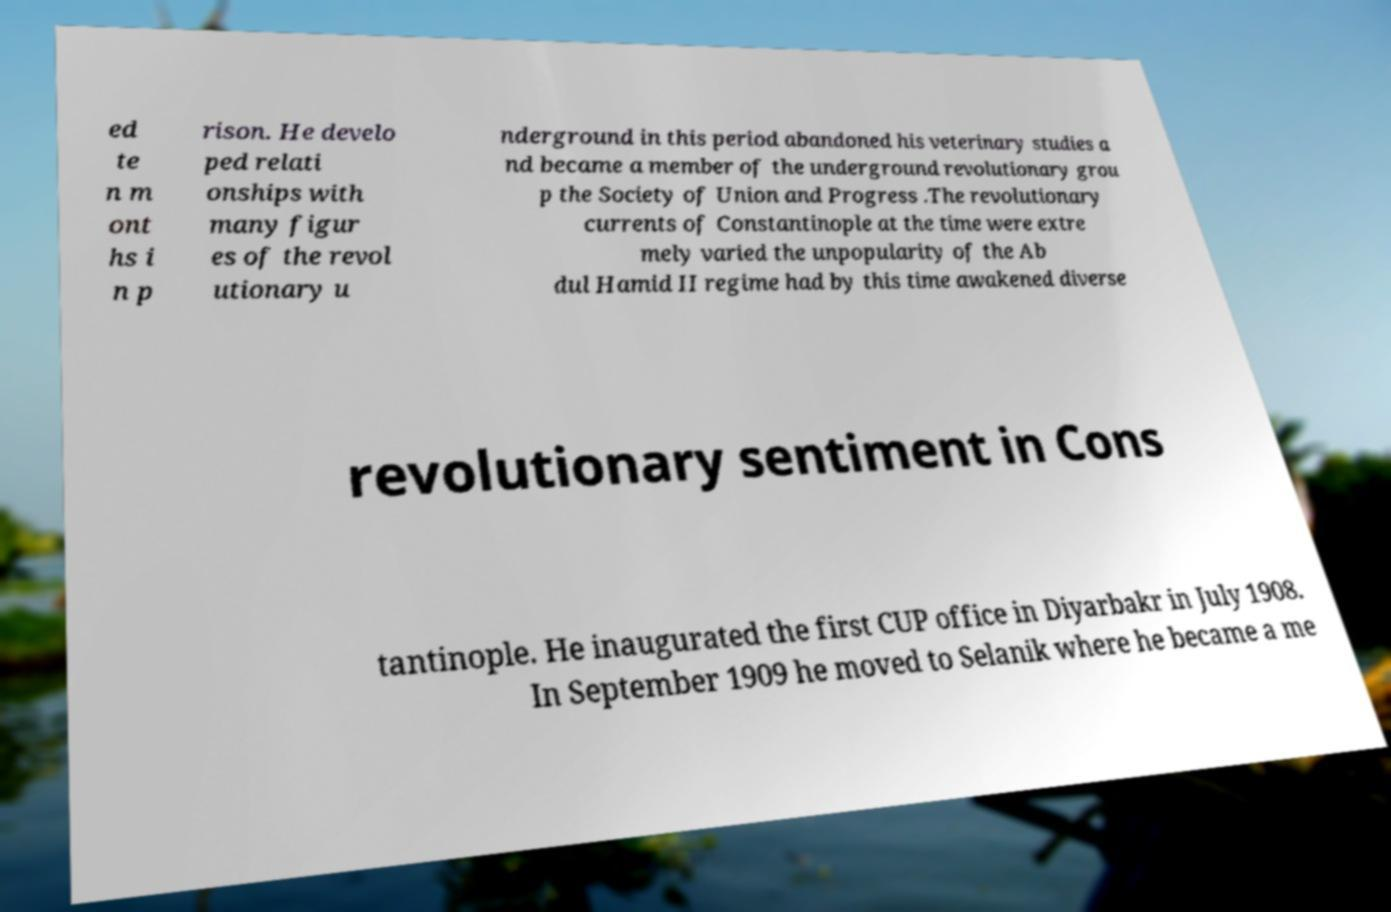I need the written content from this picture converted into text. Can you do that? ed te n m ont hs i n p rison. He develo ped relati onships with many figur es of the revol utionary u nderground in this period abandoned his veterinary studies a nd became a member of the underground revolutionary grou p the Society of Union and Progress .The revolutionary currents of Constantinople at the time were extre mely varied the unpopularity of the Ab dul Hamid II regime had by this time awakened diverse revolutionary sentiment in Cons tantinople. He inaugurated the first CUP office in Diyarbakr in July 1908. In September 1909 he moved to Selanik where he became a me 